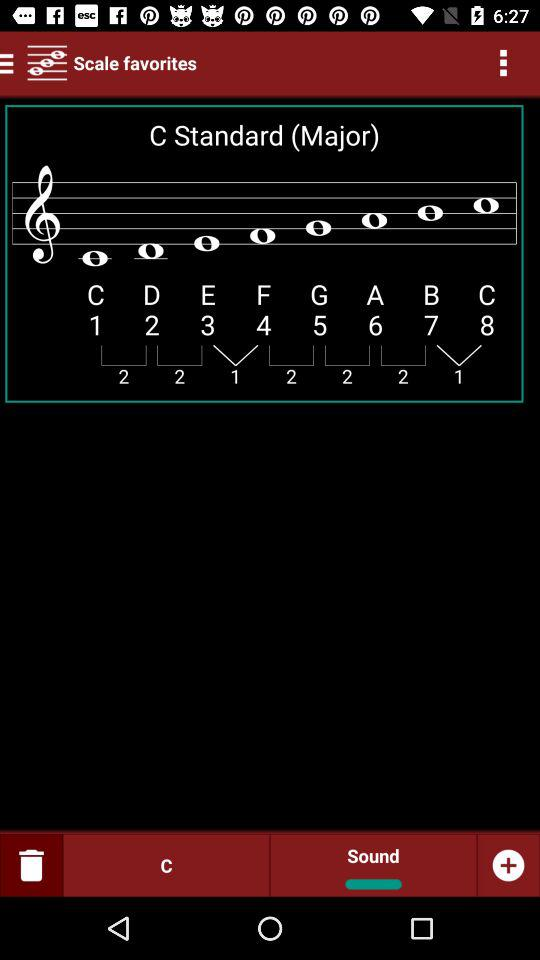How many notes are there in the scale?
Answer the question using a single word or phrase. 8 